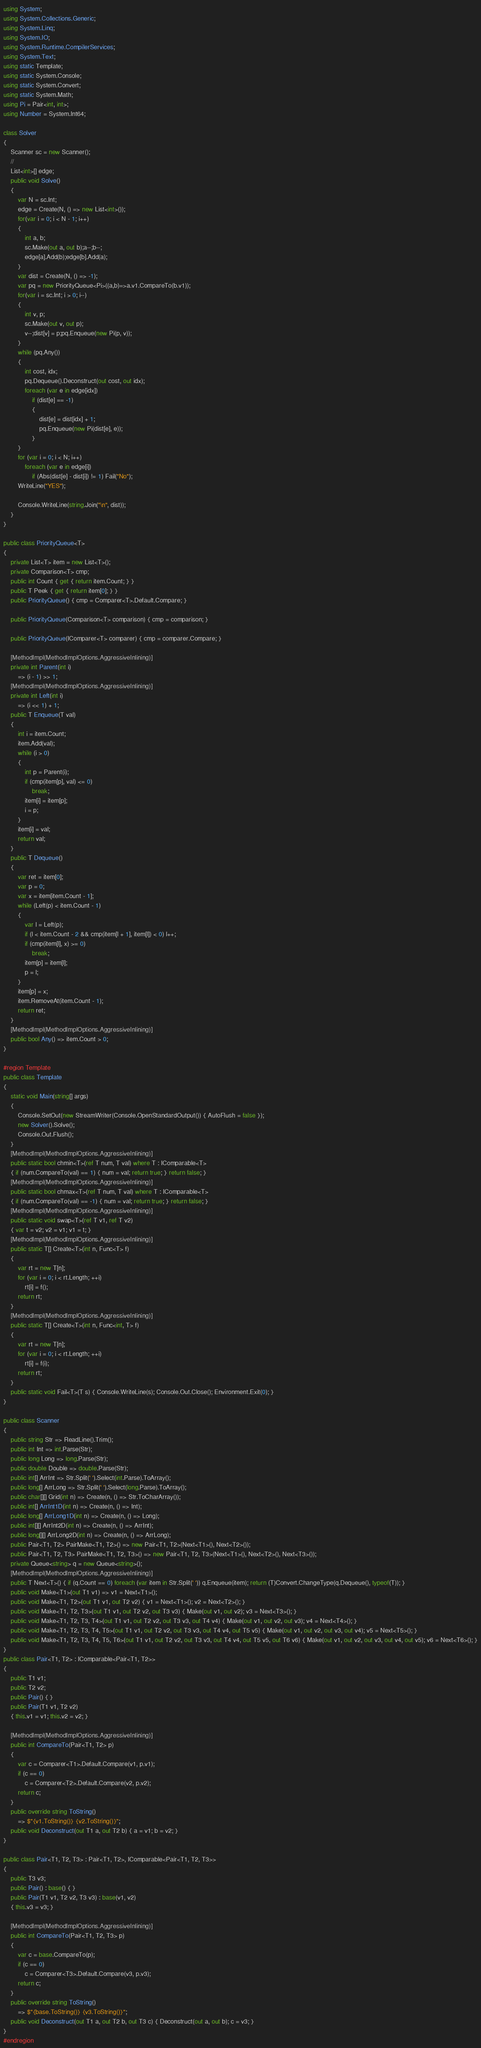Convert code to text. <code><loc_0><loc_0><loc_500><loc_500><_C#_>using System;
using System.Collections.Generic;
using System.Linq;
using System.IO;
using System.Runtime.CompilerServices;
using System.Text;
using static Template;
using static System.Console;
using static System.Convert;
using static System.Math;
using Pi = Pair<int, int>;
using Number = System.Int64;

class Solver
{
    Scanner sc = new Scanner();
    //
    List<int>[] edge;
    public void Solve()
    {
        var N = sc.Int;
        edge = Create(N, () => new List<int>());
        for(var i = 0; i < N - 1; i++)
        {
            int a, b;
            sc.Make(out a, out b);a--;b--;
            edge[a].Add(b);edge[b].Add(a);
        }
        var dist = Create(N, () => -1);
        var pq = new PriorityQueue<Pi>((a,b)=>a.v1.CompareTo(b.v1));
        for(var i = sc.Int; i > 0; i--)
        {
            int v, p;
            sc.Make(out v, out p);
            v--;dist[v] = p;pq.Enqueue(new Pi(p, v));
        }
        while (pq.Any())
        {
            int cost, idx;
            pq.Dequeue().Deconstruct(out cost, out idx);
            foreach (var e in edge[idx])
                if (dist[e] == -1)
                {
                    dist[e] = dist[idx] + 1;
                    pq.Enqueue(new Pi(dist[e], e));
                }
        }
        for (var i = 0; i < N; i++)
            foreach (var e in edge[i])
                if (Abs(dist[e] - dist[i]) != 1) Fail("No");
        WriteLine("YES");

        Console.WriteLine(string.Join("\n", dist));
    }
}

public class PriorityQueue<T>
{
    private List<T> item = new List<T>();
    private Comparison<T> cmp;
    public int Count { get { return item.Count; } }
    public T Peek { get { return item[0]; } }
    public PriorityQueue() { cmp = Comparer<T>.Default.Compare; }

    public PriorityQueue(Comparison<T> comparison) { cmp = comparison; }

    public PriorityQueue(IComparer<T> comparer) { cmp = comparer.Compare; }

    [MethodImpl(MethodImplOptions.AggressiveInlining)]
    private int Parent(int i)
        => (i - 1) >> 1;
    [MethodImpl(MethodImplOptions.AggressiveInlining)]
    private int Left(int i)
        => (i << 1) + 1;
    public T Enqueue(T val)
    {
        int i = item.Count;
        item.Add(val);
        while (i > 0)
        {
            int p = Parent(i);
            if (cmp(item[p], val) <= 0)
                break;
            item[i] = item[p];
            i = p;
        }
        item[i] = val;
        return val;
    }
    public T Dequeue()
    {
        var ret = item[0];
        var p = 0;
        var x = item[item.Count - 1];
        while (Left(p) < item.Count - 1)
        {
            var l = Left(p);
            if (l < item.Count - 2 && cmp(item[l + 1], item[l]) < 0) l++;
            if (cmp(item[l], x) >= 0)
                break;
            item[p] = item[l];
            p = l;
        }
        item[p] = x;
        item.RemoveAt(item.Count - 1);
        return ret;
    }
    [MethodImpl(MethodImplOptions.AggressiveInlining)]
    public bool Any() => item.Count > 0;
}

#region Template
public class Template
{
    static void Main(string[] args)
    {
        Console.SetOut(new StreamWriter(Console.OpenStandardOutput()) { AutoFlush = false });
        new Solver().Solve();
        Console.Out.Flush();
    }
    [MethodImpl(MethodImplOptions.AggressiveInlining)]
    public static bool chmin<T>(ref T num, T val) where T : IComparable<T>
    { if (num.CompareTo(val) == 1) { num = val; return true; } return false; }
    [MethodImpl(MethodImplOptions.AggressiveInlining)]
    public static bool chmax<T>(ref T num, T val) where T : IComparable<T>
    { if (num.CompareTo(val) == -1) { num = val; return true; } return false; }
    [MethodImpl(MethodImplOptions.AggressiveInlining)]
    public static void swap<T>(ref T v1, ref T v2)
    { var t = v2; v2 = v1; v1 = t; }
    [MethodImpl(MethodImplOptions.AggressiveInlining)]
    public static T[] Create<T>(int n, Func<T> f)
    {
        var rt = new T[n];
        for (var i = 0; i < rt.Length; ++i)
            rt[i] = f();
        return rt;
    }
    [MethodImpl(MethodImplOptions.AggressiveInlining)]
    public static T[] Create<T>(int n, Func<int, T> f)
    {
        var rt = new T[n];
        for (var i = 0; i < rt.Length; ++i)
            rt[i] = f(i);
        return rt;
    }
    public static void Fail<T>(T s) { Console.WriteLine(s); Console.Out.Close(); Environment.Exit(0); }
}

public class Scanner
{
    public string Str => ReadLine().Trim();
    public int Int => int.Parse(Str);
    public long Long => long.Parse(Str);
    public double Double => double.Parse(Str);
    public int[] ArrInt => Str.Split(' ').Select(int.Parse).ToArray();
    public long[] ArrLong => Str.Split(' ').Select(long.Parse).ToArray();
    public char[][] Grid(int n) => Create(n, () => Str.ToCharArray());
    public int[] ArrInt1D(int n) => Create(n, () => Int);
    public long[] ArrLong1D(int n) => Create(n, () => Long);
    public int[][] ArrInt2D(int n) => Create(n, () => ArrInt);
    public long[][] ArrLong2D(int n) => Create(n, () => ArrLong);
    public Pair<T1, T2> PairMake<T1, T2>() => new Pair<T1, T2>(Next<T1>(), Next<T2>());
    public Pair<T1, T2, T3> PairMake<T1, T2, T3>() => new Pair<T1, T2, T3>(Next<T1>(), Next<T2>(), Next<T3>());
    private Queue<string> q = new Queue<string>();
    [MethodImpl(MethodImplOptions.AggressiveInlining)]
    public T Next<T>() { if (q.Count == 0) foreach (var item in Str.Split(' ')) q.Enqueue(item); return (T)Convert.ChangeType(q.Dequeue(), typeof(T)); }
    public void Make<T1>(out T1 v1) => v1 = Next<T1>();
    public void Make<T1, T2>(out T1 v1, out T2 v2) { v1 = Next<T1>(); v2 = Next<T2>(); }
    public void Make<T1, T2, T3>(out T1 v1, out T2 v2, out T3 v3) { Make(out v1, out v2); v3 = Next<T3>(); }
    public void Make<T1, T2, T3, T4>(out T1 v1, out T2 v2, out T3 v3, out T4 v4) { Make(out v1, out v2, out v3); v4 = Next<T4>(); }
    public void Make<T1, T2, T3, T4, T5>(out T1 v1, out T2 v2, out T3 v3, out T4 v4, out T5 v5) { Make(out v1, out v2, out v3, out v4); v5 = Next<T5>(); }
    public void Make<T1, T2, T3, T4, T5, T6>(out T1 v1, out T2 v2, out T3 v3, out T4 v4, out T5 v5, out T6 v6) { Make(out v1, out v2, out v3, out v4, out v5); v6 = Next<T6>(); }
}
public class Pair<T1, T2> : IComparable<Pair<T1, T2>>
{
    public T1 v1;
    public T2 v2;
    public Pair() { }
    public Pair(T1 v1, T2 v2)
    { this.v1 = v1; this.v2 = v2; }

    [MethodImpl(MethodImplOptions.AggressiveInlining)]
    public int CompareTo(Pair<T1, T2> p)
    {
        var c = Comparer<T1>.Default.Compare(v1, p.v1);
        if (c == 0)
            c = Comparer<T2>.Default.Compare(v2, p.v2);
        return c;
    }
    public override string ToString()
        => $"{v1.ToString()} {v2.ToString()}";
    public void Deconstruct(out T1 a, out T2 b) { a = v1; b = v2; }
}

public class Pair<T1, T2, T3> : Pair<T1, T2>, IComparable<Pair<T1, T2, T3>>
{
    public T3 v3;
    public Pair() : base() { }
    public Pair(T1 v1, T2 v2, T3 v3) : base(v1, v2)
    { this.v3 = v3; }

    [MethodImpl(MethodImplOptions.AggressiveInlining)]
    public int CompareTo(Pair<T1, T2, T3> p)
    {
        var c = base.CompareTo(p);
        if (c == 0)
            c = Comparer<T3>.Default.Compare(v3, p.v3);
        return c;
    }
    public override string ToString()
        => $"{base.ToString()} {v3.ToString()}";
    public void Deconstruct(out T1 a, out T2 b, out T3 c) { Deconstruct(out a, out b); c = v3; }
}
#endregion
</code> 